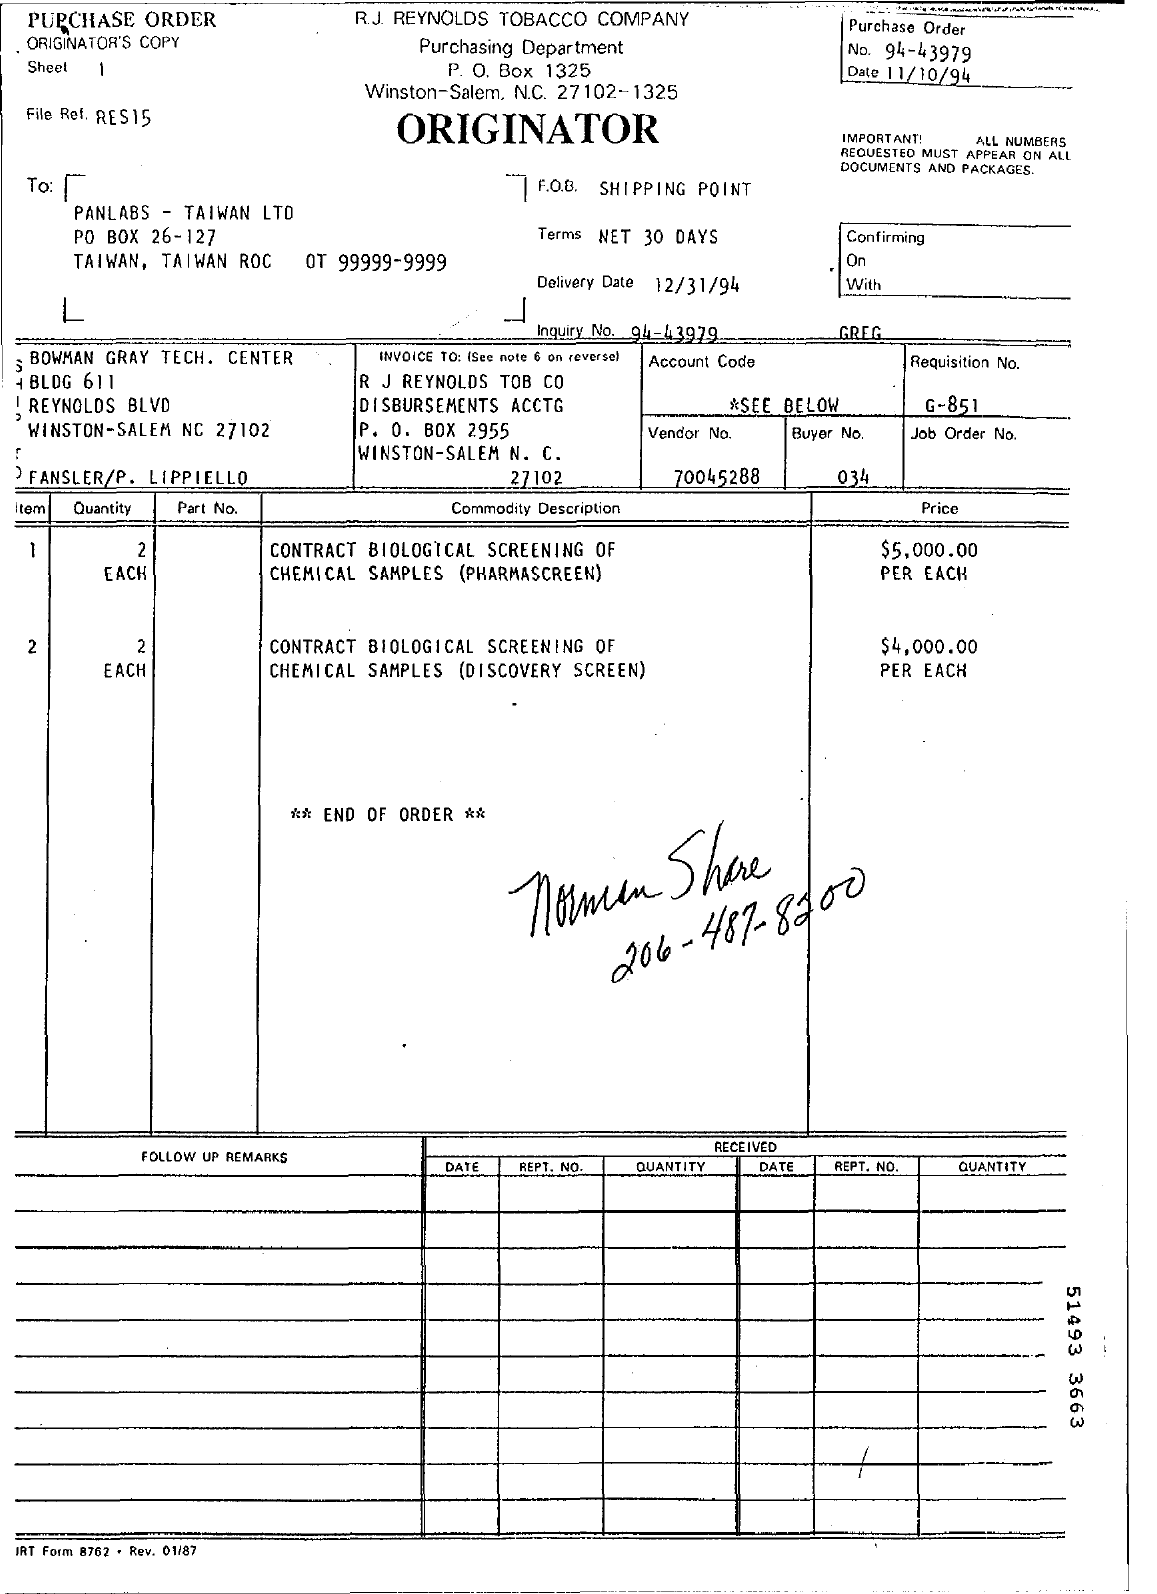What is Vendor No.?
Your answer should be very brief. 70045288. 